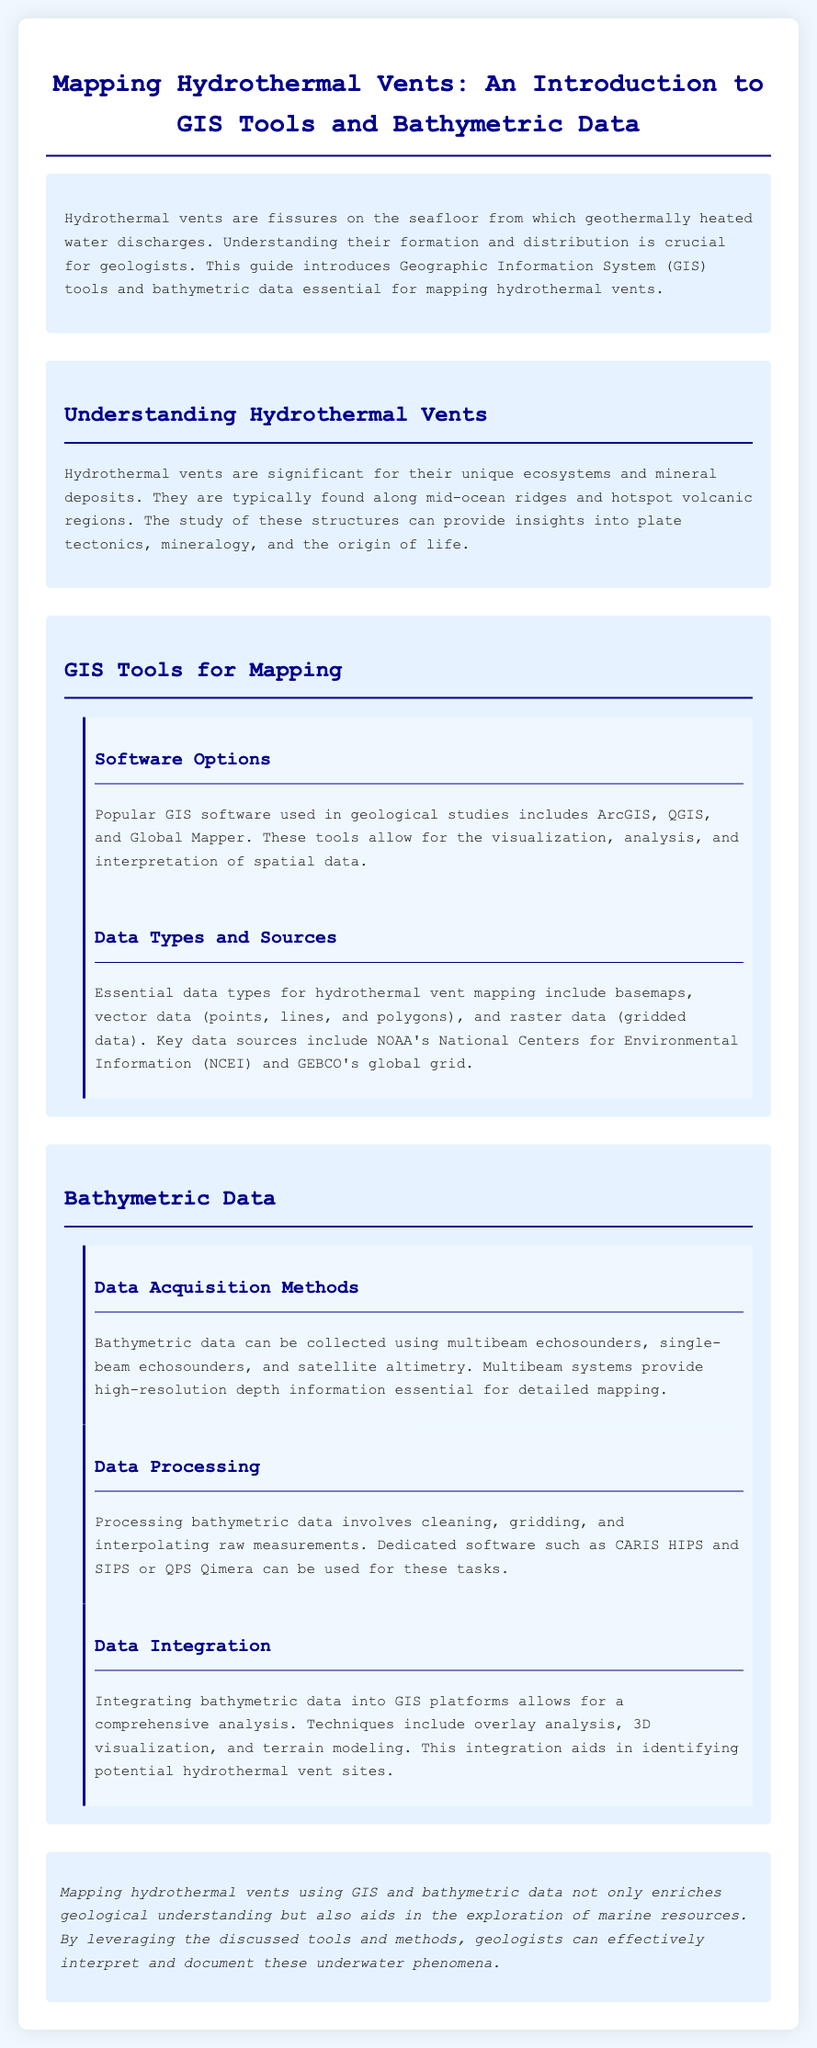what are hydrothermal vents? Hydrothermal vents are fissures on the seafloor from which geothermally heated water discharges.
Answer: fissures on the seafloor what GIS software options are mentioned? The document lists several GIS software useful in geological studies.
Answer: ArcGIS, QGIS, Global Mapper what types of data are essential for mapping hydrothermal vents? The document specifies key data types for the mapping process.
Answer: basemaps, vector data, raster data which organization provides essential data sources for hydrothermal vent mapping? The document mentions a specific organization crucial for data.
Answer: NOAA what data acquisition method provides high-resolution depth information? The document discusses various methods for collecting bathymetric data.
Answer: multibeam echosounders what is the main purpose of integrating bathymetric data into GIS? The document outlines the significance of this integration for analysis.
Answer: comprehensive analysis what is a key processing software mentioned for bathymetric data? The document identifies software used for processing bathymetric data.
Answer: CARIS HIPS how does mapping hydrothermal vents contribute to geology? The document concludes with a statement on the impact of mapping.
Answer: enriches geological understanding 